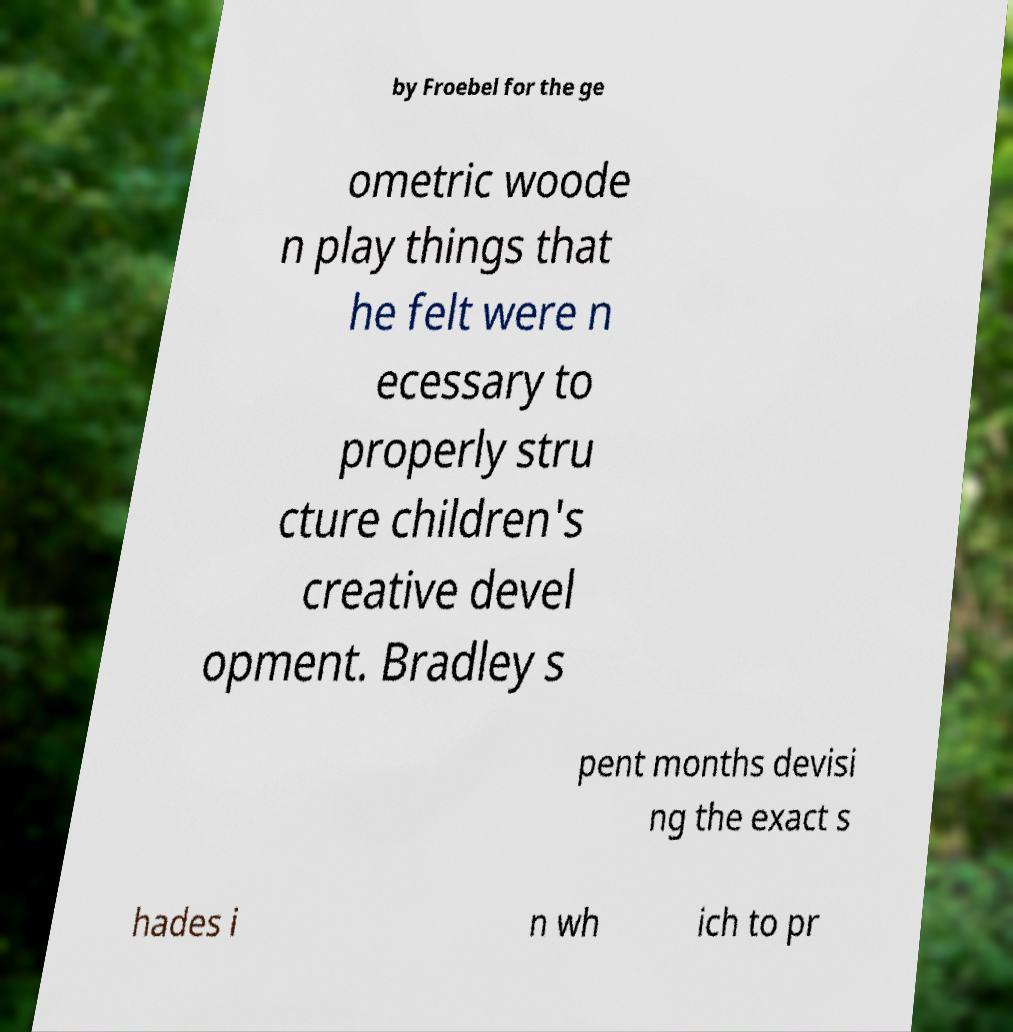There's text embedded in this image that I need extracted. Can you transcribe it verbatim? by Froebel for the ge ometric woode n play things that he felt were n ecessary to properly stru cture children's creative devel opment. Bradley s pent months devisi ng the exact s hades i n wh ich to pr 